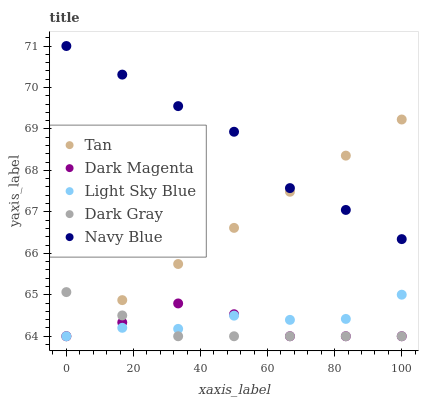Does Dark Gray have the minimum area under the curve?
Answer yes or no. Yes. Does Navy Blue have the maximum area under the curve?
Answer yes or no. Yes. Does Tan have the minimum area under the curve?
Answer yes or no. No. Does Tan have the maximum area under the curve?
Answer yes or no. No. Is Tan the smoothest?
Answer yes or no. Yes. Is Navy Blue the roughest?
Answer yes or no. Yes. Is Navy Blue the smoothest?
Answer yes or no. No. Is Tan the roughest?
Answer yes or no. No. Does Dark Gray have the lowest value?
Answer yes or no. Yes. Does Navy Blue have the lowest value?
Answer yes or no. No. Does Navy Blue have the highest value?
Answer yes or no. Yes. Does Tan have the highest value?
Answer yes or no. No. Is Dark Magenta less than Navy Blue?
Answer yes or no. Yes. Is Navy Blue greater than Dark Gray?
Answer yes or no. Yes. Does Tan intersect Dark Gray?
Answer yes or no. Yes. Is Tan less than Dark Gray?
Answer yes or no. No. Is Tan greater than Dark Gray?
Answer yes or no. No. Does Dark Magenta intersect Navy Blue?
Answer yes or no. No. 